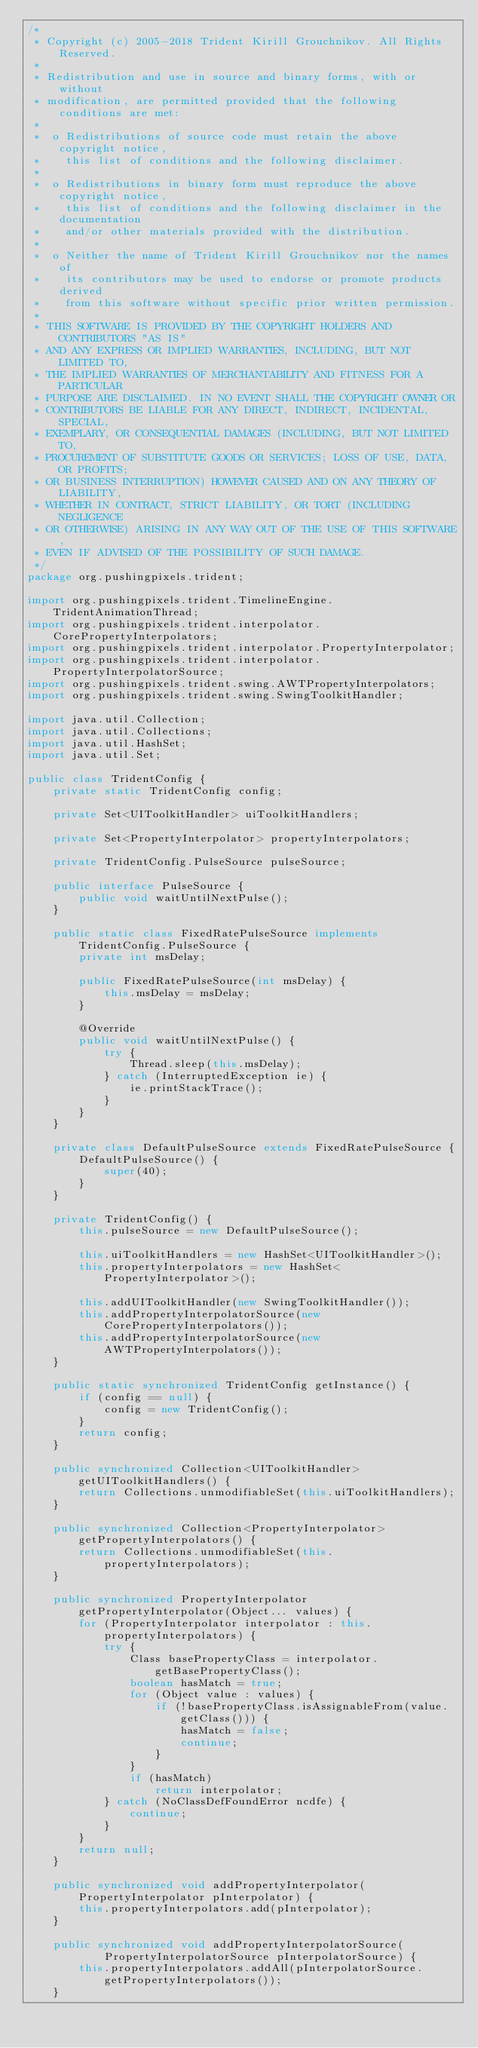Convert code to text. <code><loc_0><loc_0><loc_500><loc_500><_Java_>/*
 * Copyright (c) 2005-2018 Trident Kirill Grouchnikov. All Rights Reserved.
 *
 * Redistribution and use in source and binary forms, with or without
 * modification, are permitted provided that the following conditions are met:
 *
 *  o Redistributions of source code must retain the above copyright notice,
 *    this list of conditions and the following disclaimer.
 *
 *  o Redistributions in binary form must reproduce the above copyright notice,
 *    this list of conditions and the following disclaimer in the documentation
 *    and/or other materials provided with the distribution.
 *
 *  o Neither the name of Trident Kirill Grouchnikov nor the names of
 *    its contributors may be used to endorse or promote products derived
 *    from this software without specific prior written permission.
 *
 * THIS SOFTWARE IS PROVIDED BY THE COPYRIGHT HOLDERS AND CONTRIBUTORS "AS IS"
 * AND ANY EXPRESS OR IMPLIED WARRANTIES, INCLUDING, BUT NOT LIMITED TO,
 * THE IMPLIED WARRANTIES OF MERCHANTABILITY AND FITNESS FOR A PARTICULAR
 * PURPOSE ARE DISCLAIMED. IN NO EVENT SHALL THE COPYRIGHT OWNER OR
 * CONTRIBUTORS BE LIABLE FOR ANY DIRECT, INDIRECT, INCIDENTAL, SPECIAL,
 * EXEMPLARY, OR CONSEQUENTIAL DAMAGES (INCLUDING, BUT NOT LIMITED TO,
 * PROCUREMENT OF SUBSTITUTE GOODS OR SERVICES; LOSS OF USE, DATA, OR PROFITS;
 * OR BUSINESS INTERRUPTION) HOWEVER CAUSED AND ON ANY THEORY OF LIABILITY,
 * WHETHER IN CONTRACT, STRICT LIABILITY, OR TORT (INCLUDING NEGLIGENCE
 * OR OTHERWISE) ARISING IN ANY WAY OUT OF THE USE OF THIS SOFTWARE,
 * EVEN IF ADVISED OF THE POSSIBILITY OF SUCH DAMAGE.
 */
package org.pushingpixels.trident;

import org.pushingpixels.trident.TimelineEngine.TridentAnimationThread;
import org.pushingpixels.trident.interpolator.CorePropertyInterpolators;
import org.pushingpixels.trident.interpolator.PropertyInterpolator;
import org.pushingpixels.trident.interpolator.PropertyInterpolatorSource;
import org.pushingpixels.trident.swing.AWTPropertyInterpolators;
import org.pushingpixels.trident.swing.SwingToolkitHandler;

import java.util.Collection;
import java.util.Collections;
import java.util.HashSet;
import java.util.Set;

public class TridentConfig {
    private static TridentConfig config;

    private Set<UIToolkitHandler> uiToolkitHandlers;

    private Set<PropertyInterpolator> propertyInterpolators;

    private TridentConfig.PulseSource pulseSource;

    public interface PulseSource {
        public void waitUntilNextPulse();
    }

    public static class FixedRatePulseSource implements TridentConfig.PulseSource {
        private int msDelay;

        public FixedRatePulseSource(int msDelay) {
            this.msDelay = msDelay;
        }

        @Override
        public void waitUntilNextPulse() {
            try {
                Thread.sleep(this.msDelay);
            } catch (InterruptedException ie) {
                ie.printStackTrace();
            }
        }
    }

    private class DefaultPulseSource extends FixedRatePulseSource {
        DefaultPulseSource() {
            super(40);
        }
    }

    private TridentConfig() {
        this.pulseSource = new DefaultPulseSource();

        this.uiToolkitHandlers = new HashSet<UIToolkitHandler>();
        this.propertyInterpolators = new HashSet<PropertyInterpolator>();

        this.addUIToolkitHandler(new SwingToolkitHandler());
        this.addPropertyInterpolatorSource(new CorePropertyInterpolators());
        this.addPropertyInterpolatorSource(new AWTPropertyInterpolators());
    }

    public static synchronized TridentConfig getInstance() {
        if (config == null) {
            config = new TridentConfig();
        }
        return config;
    }

    public synchronized Collection<UIToolkitHandler> getUIToolkitHandlers() {
        return Collections.unmodifiableSet(this.uiToolkitHandlers);
    }

    public synchronized Collection<PropertyInterpolator> getPropertyInterpolators() {
        return Collections.unmodifiableSet(this.propertyInterpolators);
    }

    public synchronized PropertyInterpolator getPropertyInterpolator(Object... values) {
        for (PropertyInterpolator interpolator : this.propertyInterpolators) {
            try {
                Class basePropertyClass = interpolator.getBasePropertyClass();
                boolean hasMatch = true;
                for (Object value : values) {
                    if (!basePropertyClass.isAssignableFrom(value.getClass())) {
                        hasMatch = false;
                        continue;
                    }
                }
                if (hasMatch)
                    return interpolator;
            } catch (NoClassDefFoundError ncdfe) {
                continue;
            }
        }
        return null;
    }

    public synchronized void addPropertyInterpolator(PropertyInterpolator pInterpolator) {
        this.propertyInterpolators.add(pInterpolator);
    }

    public synchronized void addPropertyInterpolatorSource(
            PropertyInterpolatorSource pInterpolatorSource) {
        this.propertyInterpolators.addAll(pInterpolatorSource.getPropertyInterpolators());
    }
</code> 